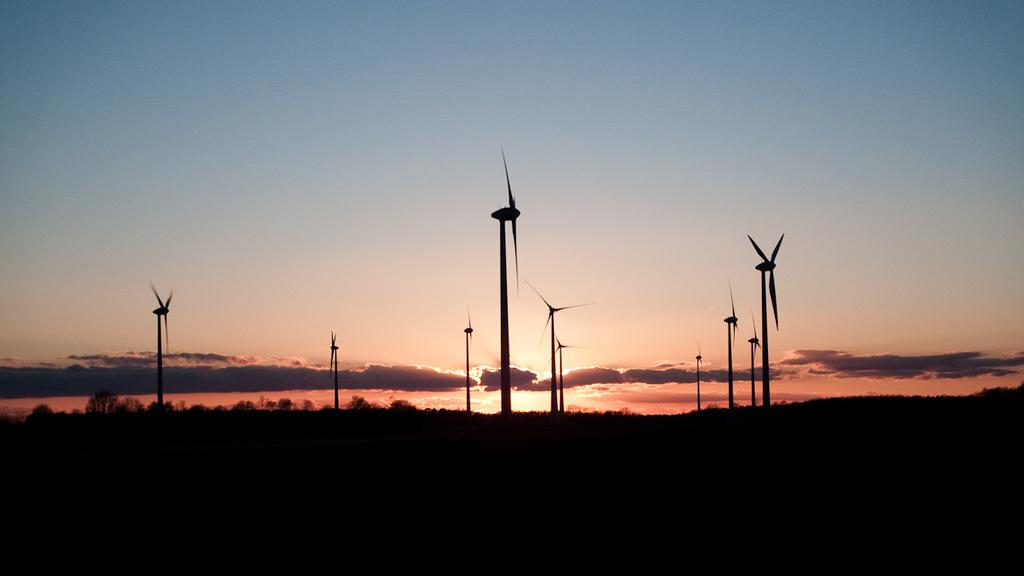What structures can be seen in the image? There are windmills in the image. What type of vegetation is present in the image? There are trees in the image. What is visible in the background of the image? The sky is visible in the image. What can be observed in the sky? Clouds are present in the sky. Where are the scissors located in the image? There are no scissors present in the image. What type of balloon can be seen floating in the sky? There is no balloon present in the image; only clouds are visible in the sky. 